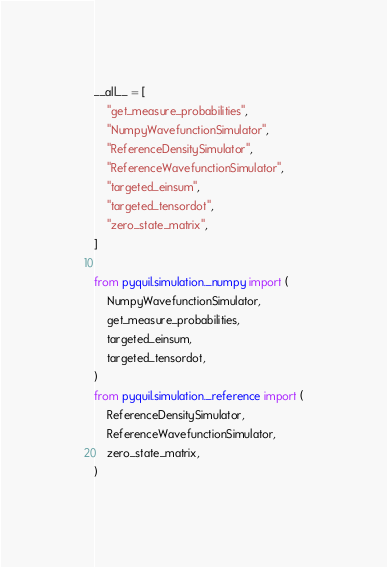<code> <loc_0><loc_0><loc_500><loc_500><_Python_>__all__ = [
    "get_measure_probabilities",
    "NumpyWavefunctionSimulator",
    "ReferenceDensitySimulator",
    "ReferenceWavefunctionSimulator",
    "targeted_einsum",
    "targeted_tensordot",
    "zero_state_matrix",
]

from pyquil.simulation._numpy import (
    NumpyWavefunctionSimulator,
    get_measure_probabilities,
    targeted_einsum,
    targeted_tensordot,
)
from pyquil.simulation._reference import (
    ReferenceDensitySimulator,
    ReferenceWavefunctionSimulator,
    zero_state_matrix,
)
</code> 